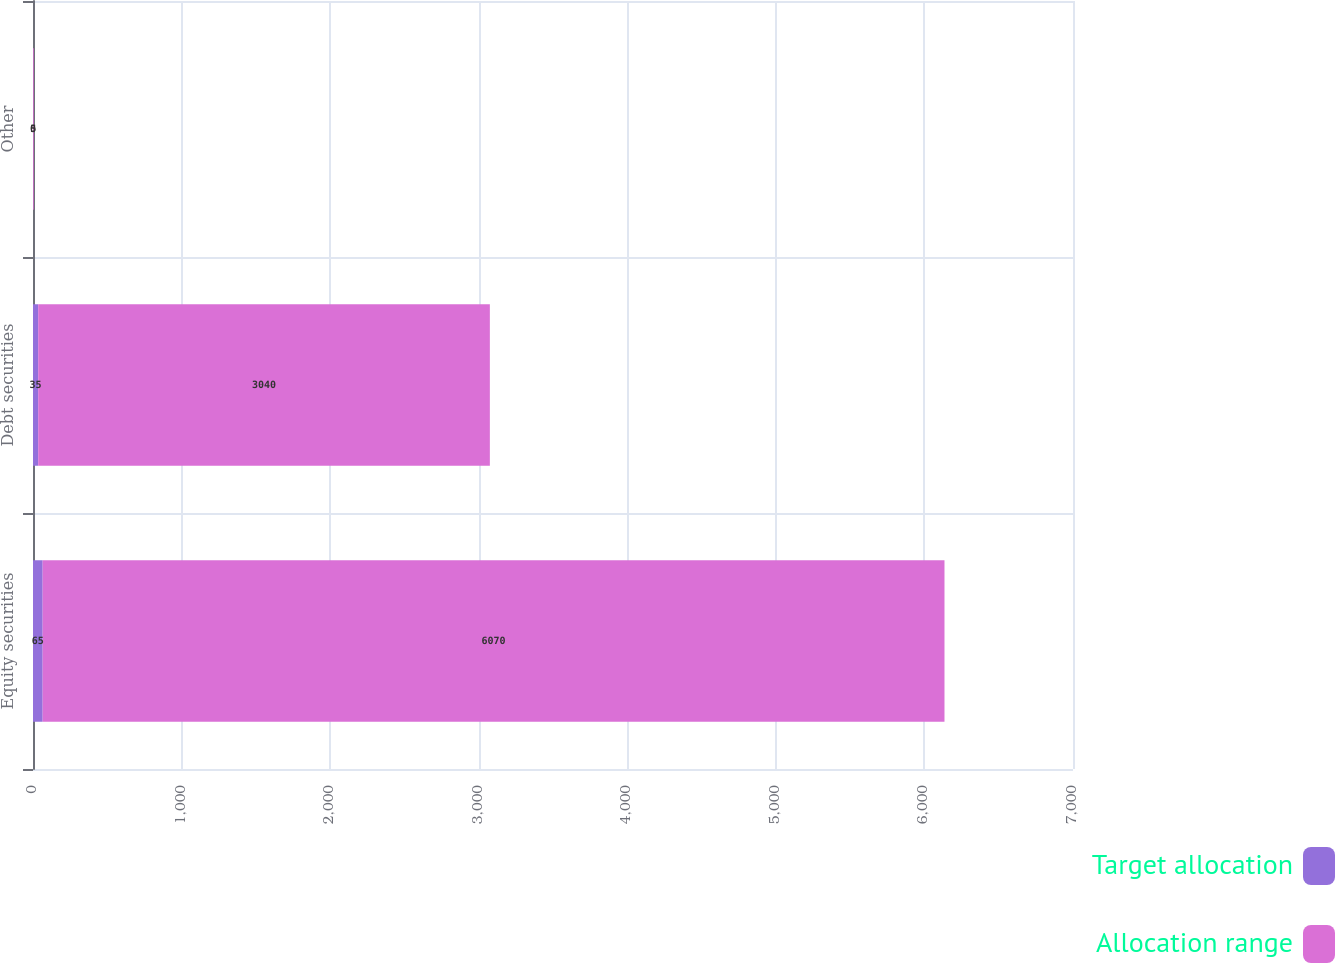Convert chart. <chart><loc_0><loc_0><loc_500><loc_500><stacked_bar_chart><ecel><fcel>Equity securities<fcel>Debt securities<fcel>Other<nl><fcel>Target allocation<fcel>65<fcel>35<fcel>0<nl><fcel>Allocation range<fcel>6070<fcel>3040<fcel>5<nl></chart> 